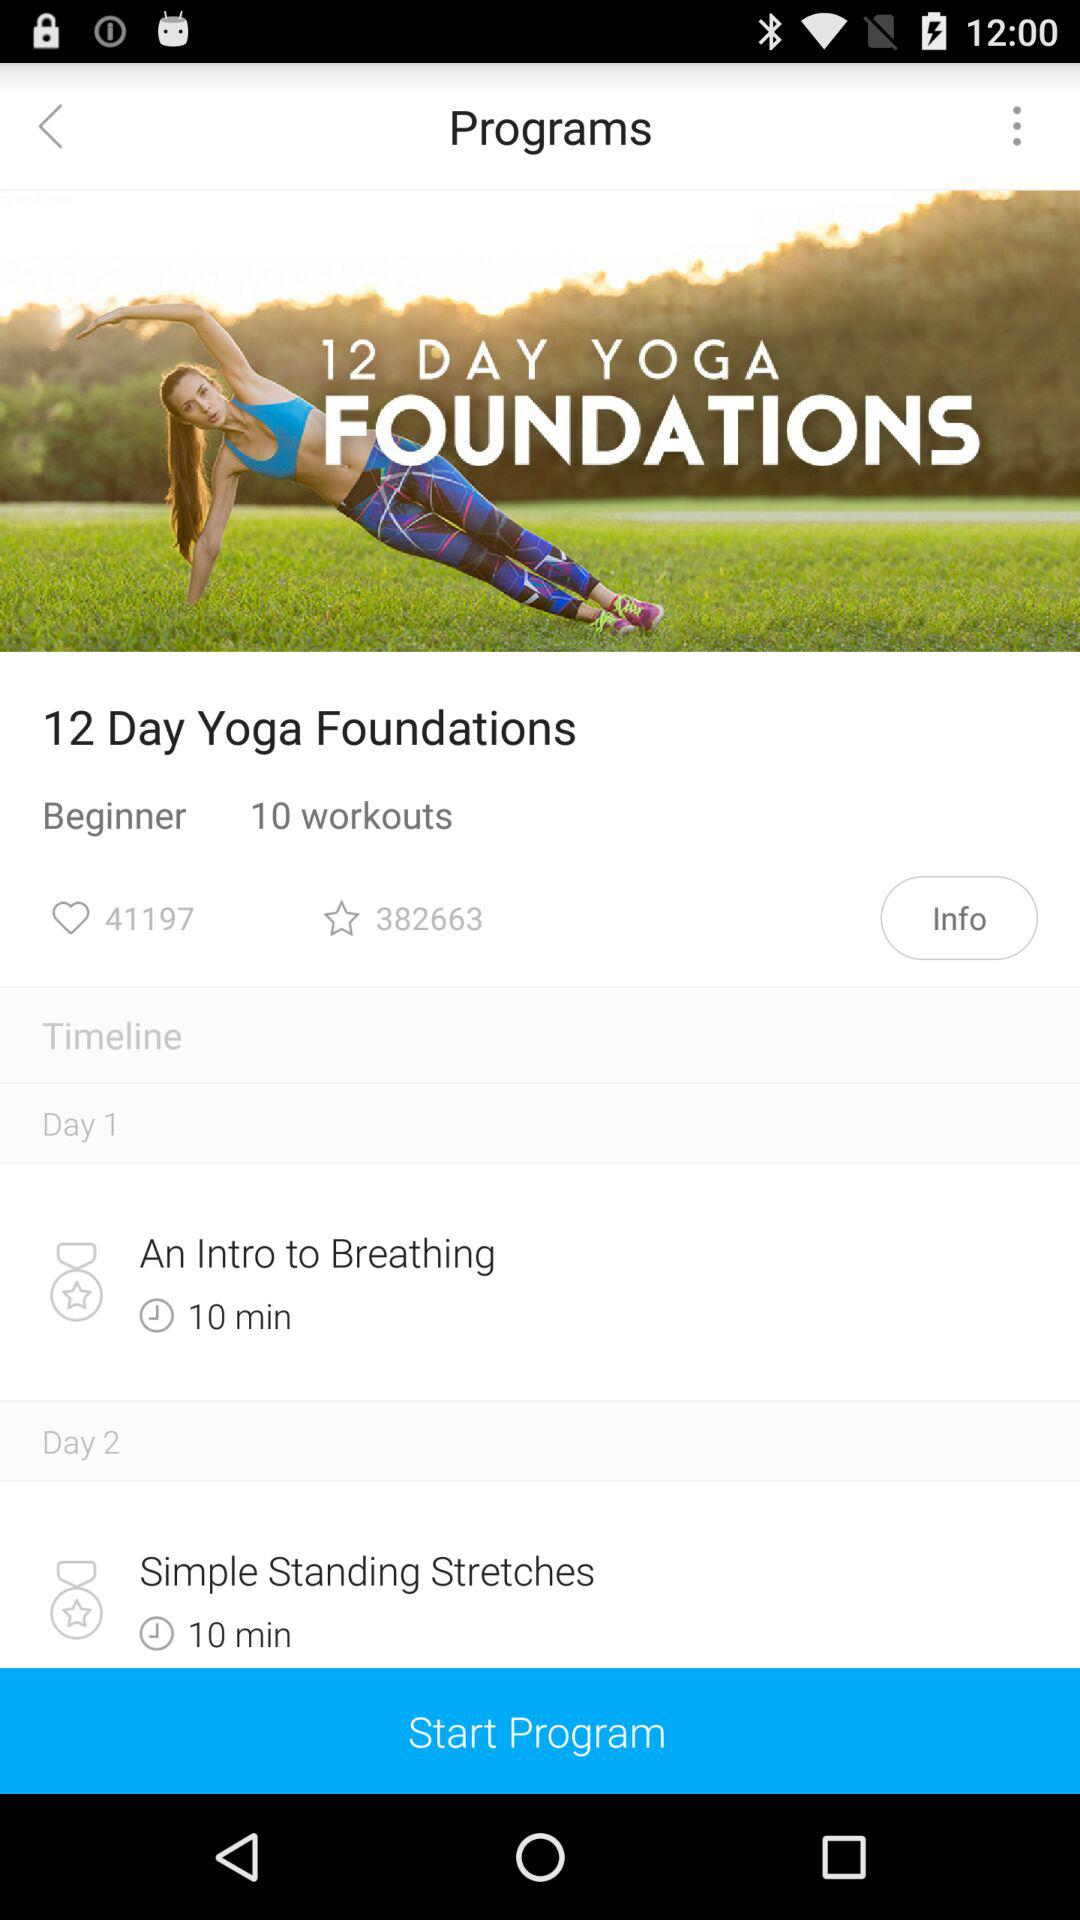How many people have marked the program "12 Day Yoga Foundations" as a favorite? There are 382663 people. 